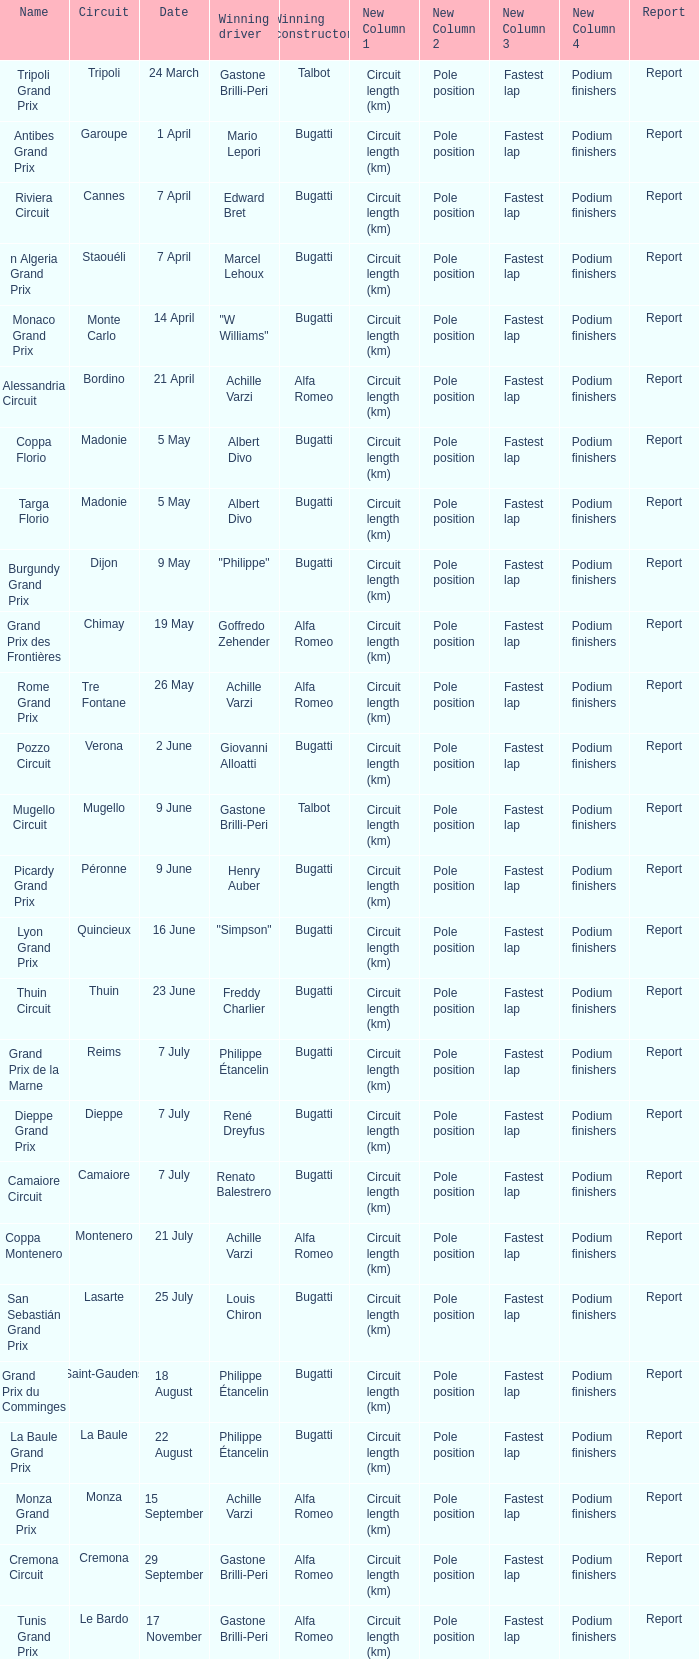What Winning driver has a Name of mugello circuit? Gastone Brilli-Peri. 